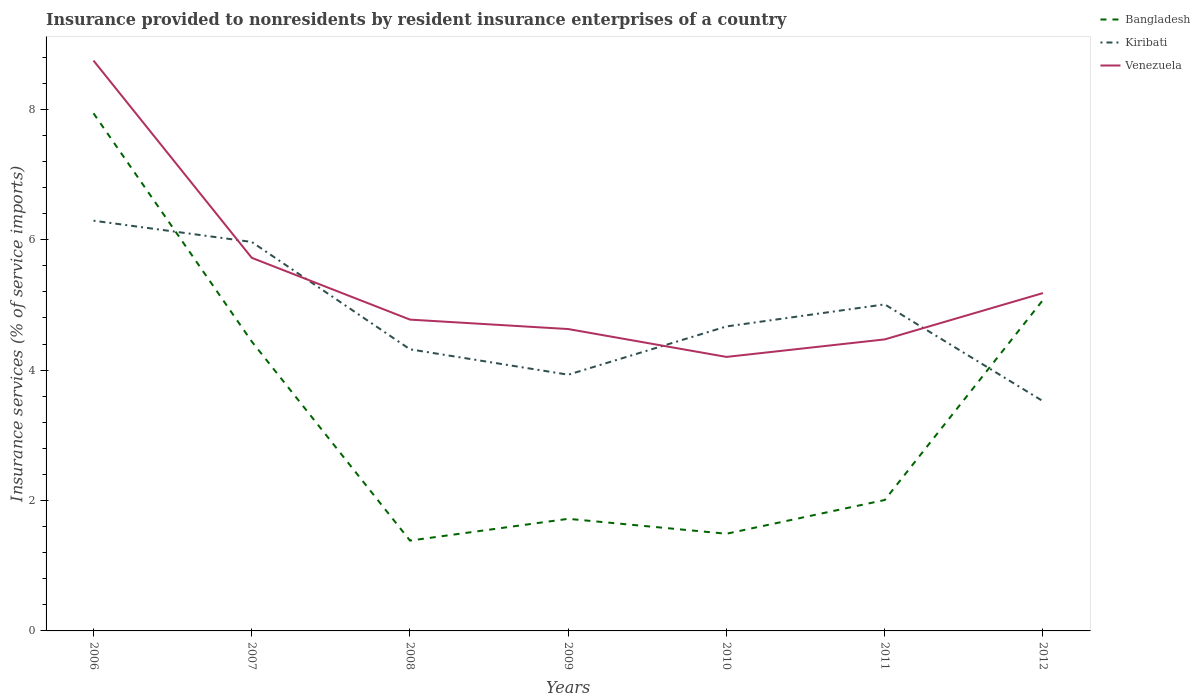Across all years, what is the maximum insurance provided to nonresidents in Bangladesh?
Ensure brevity in your answer.  1.39. What is the total insurance provided to nonresidents in Kiribati in the graph?
Provide a succinct answer. 1.48. What is the difference between the highest and the second highest insurance provided to nonresidents in Venezuela?
Your answer should be compact. 4.55. What is the difference between the highest and the lowest insurance provided to nonresidents in Kiribati?
Keep it short and to the point. 3. What is the difference between two consecutive major ticks on the Y-axis?
Give a very brief answer. 2. Where does the legend appear in the graph?
Give a very brief answer. Top right. How are the legend labels stacked?
Make the answer very short. Vertical. What is the title of the graph?
Offer a very short reply. Insurance provided to nonresidents by resident insurance enterprises of a country. Does "India" appear as one of the legend labels in the graph?
Ensure brevity in your answer.  No. What is the label or title of the X-axis?
Your response must be concise. Years. What is the label or title of the Y-axis?
Provide a succinct answer. Insurance services (% of service imports). What is the Insurance services (% of service imports) of Bangladesh in 2006?
Offer a terse response. 7.94. What is the Insurance services (% of service imports) in Kiribati in 2006?
Offer a very short reply. 6.29. What is the Insurance services (% of service imports) in Venezuela in 2006?
Make the answer very short. 8.75. What is the Insurance services (% of service imports) in Bangladesh in 2007?
Provide a succinct answer. 4.44. What is the Insurance services (% of service imports) in Kiribati in 2007?
Your answer should be compact. 5.97. What is the Insurance services (% of service imports) of Venezuela in 2007?
Provide a succinct answer. 5.72. What is the Insurance services (% of service imports) in Bangladesh in 2008?
Your answer should be very brief. 1.39. What is the Insurance services (% of service imports) of Kiribati in 2008?
Your answer should be compact. 4.32. What is the Insurance services (% of service imports) of Venezuela in 2008?
Offer a terse response. 4.77. What is the Insurance services (% of service imports) in Bangladesh in 2009?
Make the answer very short. 1.72. What is the Insurance services (% of service imports) in Kiribati in 2009?
Your response must be concise. 3.93. What is the Insurance services (% of service imports) in Venezuela in 2009?
Your answer should be compact. 4.63. What is the Insurance services (% of service imports) in Bangladesh in 2010?
Offer a very short reply. 1.49. What is the Insurance services (% of service imports) of Kiribati in 2010?
Make the answer very short. 4.67. What is the Insurance services (% of service imports) of Venezuela in 2010?
Offer a very short reply. 4.2. What is the Insurance services (% of service imports) in Bangladesh in 2011?
Your answer should be very brief. 2.01. What is the Insurance services (% of service imports) in Kiribati in 2011?
Offer a terse response. 5.01. What is the Insurance services (% of service imports) of Venezuela in 2011?
Keep it short and to the point. 4.47. What is the Insurance services (% of service imports) of Bangladesh in 2012?
Ensure brevity in your answer.  5.08. What is the Insurance services (% of service imports) in Kiribati in 2012?
Your response must be concise. 3.52. What is the Insurance services (% of service imports) of Venezuela in 2012?
Make the answer very short. 5.18. Across all years, what is the maximum Insurance services (% of service imports) of Bangladesh?
Your answer should be compact. 7.94. Across all years, what is the maximum Insurance services (% of service imports) of Kiribati?
Your answer should be very brief. 6.29. Across all years, what is the maximum Insurance services (% of service imports) of Venezuela?
Keep it short and to the point. 8.75. Across all years, what is the minimum Insurance services (% of service imports) in Bangladesh?
Give a very brief answer. 1.39. Across all years, what is the minimum Insurance services (% of service imports) of Kiribati?
Ensure brevity in your answer.  3.52. Across all years, what is the minimum Insurance services (% of service imports) of Venezuela?
Provide a short and direct response. 4.2. What is the total Insurance services (% of service imports) of Bangladesh in the graph?
Ensure brevity in your answer.  24.06. What is the total Insurance services (% of service imports) of Kiribati in the graph?
Your answer should be very brief. 33.71. What is the total Insurance services (% of service imports) of Venezuela in the graph?
Offer a terse response. 37.73. What is the difference between the Insurance services (% of service imports) in Bangladesh in 2006 and that in 2007?
Make the answer very short. 3.5. What is the difference between the Insurance services (% of service imports) of Kiribati in 2006 and that in 2007?
Make the answer very short. 0.33. What is the difference between the Insurance services (% of service imports) of Venezuela in 2006 and that in 2007?
Provide a succinct answer. 3.03. What is the difference between the Insurance services (% of service imports) of Bangladesh in 2006 and that in 2008?
Give a very brief answer. 6.55. What is the difference between the Insurance services (% of service imports) of Kiribati in 2006 and that in 2008?
Ensure brevity in your answer.  1.97. What is the difference between the Insurance services (% of service imports) of Venezuela in 2006 and that in 2008?
Provide a succinct answer. 3.97. What is the difference between the Insurance services (% of service imports) of Bangladesh in 2006 and that in 2009?
Ensure brevity in your answer.  6.22. What is the difference between the Insurance services (% of service imports) of Kiribati in 2006 and that in 2009?
Offer a terse response. 2.36. What is the difference between the Insurance services (% of service imports) of Venezuela in 2006 and that in 2009?
Provide a short and direct response. 4.12. What is the difference between the Insurance services (% of service imports) of Bangladesh in 2006 and that in 2010?
Your answer should be compact. 6.45. What is the difference between the Insurance services (% of service imports) of Kiribati in 2006 and that in 2010?
Make the answer very short. 1.62. What is the difference between the Insurance services (% of service imports) of Venezuela in 2006 and that in 2010?
Provide a short and direct response. 4.55. What is the difference between the Insurance services (% of service imports) in Bangladesh in 2006 and that in 2011?
Your response must be concise. 5.93. What is the difference between the Insurance services (% of service imports) in Kiribati in 2006 and that in 2011?
Offer a terse response. 1.28. What is the difference between the Insurance services (% of service imports) in Venezuela in 2006 and that in 2011?
Keep it short and to the point. 4.28. What is the difference between the Insurance services (% of service imports) of Bangladesh in 2006 and that in 2012?
Your answer should be compact. 2.86. What is the difference between the Insurance services (% of service imports) of Kiribati in 2006 and that in 2012?
Make the answer very short. 2.77. What is the difference between the Insurance services (% of service imports) of Venezuela in 2006 and that in 2012?
Make the answer very short. 3.57. What is the difference between the Insurance services (% of service imports) of Bangladesh in 2007 and that in 2008?
Offer a terse response. 3.05. What is the difference between the Insurance services (% of service imports) in Kiribati in 2007 and that in 2008?
Offer a terse response. 1.65. What is the difference between the Insurance services (% of service imports) in Venezuela in 2007 and that in 2008?
Provide a succinct answer. 0.95. What is the difference between the Insurance services (% of service imports) in Bangladesh in 2007 and that in 2009?
Keep it short and to the point. 2.72. What is the difference between the Insurance services (% of service imports) in Kiribati in 2007 and that in 2009?
Make the answer very short. 2.04. What is the difference between the Insurance services (% of service imports) of Venezuela in 2007 and that in 2009?
Ensure brevity in your answer.  1.09. What is the difference between the Insurance services (% of service imports) of Bangladesh in 2007 and that in 2010?
Make the answer very short. 2.95. What is the difference between the Insurance services (% of service imports) in Kiribati in 2007 and that in 2010?
Make the answer very short. 1.3. What is the difference between the Insurance services (% of service imports) in Venezuela in 2007 and that in 2010?
Ensure brevity in your answer.  1.52. What is the difference between the Insurance services (% of service imports) in Bangladesh in 2007 and that in 2011?
Make the answer very short. 2.43. What is the difference between the Insurance services (% of service imports) in Kiribati in 2007 and that in 2011?
Your answer should be compact. 0.96. What is the difference between the Insurance services (% of service imports) of Venezuela in 2007 and that in 2011?
Your answer should be very brief. 1.25. What is the difference between the Insurance services (% of service imports) of Bangladesh in 2007 and that in 2012?
Your answer should be compact. -0.64. What is the difference between the Insurance services (% of service imports) of Kiribati in 2007 and that in 2012?
Keep it short and to the point. 2.44. What is the difference between the Insurance services (% of service imports) of Venezuela in 2007 and that in 2012?
Provide a succinct answer. 0.54. What is the difference between the Insurance services (% of service imports) in Bangladesh in 2008 and that in 2009?
Make the answer very short. -0.33. What is the difference between the Insurance services (% of service imports) of Kiribati in 2008 and that in 2009?
Your answer should be compact. 0.39. What is the difference between the Insurance services (% of service imports) in Venezuela in 2008 and that in 2009?
Provide a succinct answer. 0.14. What is the difference between the Insurance services (% of service imports) of Bangladesh in 2008 and that in 2010?
Offer a very short reply. -0.1. What is the difference between the Insurance services (% of service imports) of Kiribati in 2008 and that in 2010?
Offer a very short reply. -0.35. What is the difference between the Insurance services (% of service imports) in Venezuela in 2008 and that in 2010?
Ensure brevity in your answer.  0.57. What is the difference between the Insurance services (% of service imports) in Bangladesh in 2008 and that in 2011?
Your response must be concise. -0.62. What is the difference between the Insurance services (% of service imports) in Kiribati in 2008 and that in 2011?
Ensure brevity in your answer.  -0.69. What is the difference between the Insurance services (% of service imports) of Venezuela in 2008 and that in 2011?
Keep it short and to the point. 0.3. What is the difference between the Insurance services (% of service imports) of Bangladesh in 2008 and that in 2012?
Give a very brief answer. -3.69. What is the difference between the Insurance services (% of service imports) in Kiribati in 2008 and that in 2012?
Make the answer very short. 0.8. What is the difference between the Insurance services (% of service imports) in Venezuela in 2008 and that in 2012?
Provide a short and direct response. -0.41. What is the difference between the Insurance services (% of service imports) in Bangladesh in 2009 and that in 2010?
Ensure brevity in your answer.  0.23. What is the difference between the Insurance services (% of service imports) of Kiribati in 2009 and that in 2010?
Provide a succinct answer. -0.74. What is the difference between the Insurance services (% of service imports) in Venezuela in 2009 and that in 2010?
Your answer should be compact. 0.43. What is the difference between the Insurance services (% of service imports) in Bangladesh in 2009 and that in 2011?
Your response must be concise. -0.29. What is the difference between the Insurance services (% of service imports) in Kiribati in 2009 and that in 2011?
Make the answer very short. -1.08. What is the difference between the Insurance services (% of service imports) in Venezuela in 2009 and that in 2011?
Provide a succinct answer. 0.16. What is the difference between the Insurance services (% of service imports) of Bangladesh in 2009 and that in 2012?
Provide a succinct answer. -3.36. What is the difference between the Insurance services (% of service imports) in Kiribati in 2009 and that in 2012?
Your response must be concise. 0.41. What is the difference between the Insurance services (% of service imports) of Venezuela in 2009 and that in 2012?
Offer a very short reply. -0.55. What is the difference between the Insurance services (% of service imports) in Bangladesh in 2010 and that in 2011?
Provide a succinct answer. -0.52. What is the difference between the Insurance services (% of service imports) in Kiribati in 2010 and that in 2011?
Your answer should be very brief. -0.34. What is the difference between the Insurance services (% of service imports) of Venezuela in 2010 and that in 2011?
Your answer should be very brief. -0.27. What is the difference between the Insurance services (% of service imports) in Bangladesh in 2010 and that in 2012?
Your answer should be very brief. -3.59. What is the difference between the Insurance services (% of service imports) in Kiribati in 2010 and that in 2012?
Your response must be concise. 1.15. What is the difference between the Insurance services (% of service imports) in Venezuela in 2010 and that in 2012?
Offer a terse response. -0.98. What is the difference between the Insurance services (% of service imports) in Bangladesh in 2011 and that in 2012?
Give a very brief answer. -3.07. What is the difference between the Insurance services (% of service imports) in Kiribati in 2011 and that in 2012?
Your answer should be compact. 1.48. What is the difference between the Insurance services (% of service imports) of Venezuela in 2011 and that in 2012?
Offer a very short reply. -0.71. What is the difference between the Insurance services (% of service imports) of Bangladesh in 2006 and the Insurance services (% of service imports) of Kiribati in 2007?
Provide a succinct answer. 1.97. What is the difference between the Insurance services (% of service imports) in Bangladesh in 2006 and the Insurance services (% of service imports) in Venezuela in 2007?
Keep it short and to the point. 2.22. What is the difference between the Insurance services (% of service imports) of Kiribati in 2006 and the Insurance services (% of service imports) of Venezuela in 2007?
Offer a very short reply. 0.57. What is the difference between the Insurance services (% of service imports) in Bangladesh in 2006 and the Insurance services (% of service imports) in Kiribati in 2008?
Offer a terse response. 3.62. What is the difference between the Insurance services (% of service imports) in Bangladesh in 2006 and the Insurance services (% of service imports) in Venezuela in 2008?
Provide a short and direct response. 3.16. What is the difference between the Insurance services (% of service imports) in Kiribati in 2006 and the Insurance services (% of service imports) in Venezuela in 2008?
Make the answer very short. 1.52. What is the difference between the Insurance services (% of service imports) in Bangladesh in 2006 and the Insurance services (% of service imports) in Kiribati in 2009?
Provide a short and direct response. 4.01. What is the difference between the Insurance services (% of service imports) in Bangladesh in 2006 and the Insurance services (% of service imports) in Venezuela in 2009?
Keep it short and to the point. 3.31. What is the difference between the Insurance services (% of service imports) in Kiribati in 2006 and the Insurance services (% of service imports) in Venezuela in 2009?
Provide a short and direct response. 1.66. What is the difference between the Insurance services (% of service imports) in Bangladesh in 2006 and the Insurance services (% of service imports) in Kiribati in 2010?
Provide a succinct answer. 3.27. What is the difference between the Insurance services (% of service imports) in Bangladesh in 2006 and the Insurance services (% of service imports) in Venezuela in 2010?
Provide a succinct answer. 3.74. What is the difference between the Insurance services (% of service imports) of Kiribati in 2006 and the Insurance services (% of service imports) of Venezuela in 2010?
Ensure brevity in your answer.  2.09. What is the difference between the Insurance services (% of service imports) of Bangladesh in 2006 and the Insurance services (% of service imports) of Kiribati in 2011?
Your answer should be compact. 2.93. What is the difference between the Insurance services (% of service imports) of Bangladesh in 2006 and the Insurance services (% of service imports) of Venezuela in 2011?
Ensure brevity in your answer.  3.47. What is the difference between the Insurance services (% of service imports) of Kiribati in 2006 and the Insurance services (% of service imports) of Venezuela in 2011?
Your answer should be very brief. 1.82. What is the difference between the Insurance services (% of service imports) in Bangladesh in 2006 and the Insurance services (% of service imports) in Kiribati in 2012?
Provide a short and direct response. 4.42. What is the difference between the Insurance services (% of service imports) of Bangladesh in 2006 and the Insurance services (% of service imports) of Venezuela in 2012?
Provide a short and direct response. 2.76. What is the difference between the Insurance services (% of service imports) of Kiribati in 2006 and the Insurance services (% of service imports) of Venezuela in 2012?
Offer a terse response. 1.11. What is the difference between the Insurance services (% of service imports) in Bangladesh in 2007 and the Insurance services (% of service imports) in Kiribati in 2008?
Keep it short and to the point. 0.12. What is the difference between the Insurance services (% of service imports) in Bangladesh in 2007 and the Insurance services (% of service imports) in Venezuela in 2008?
Your answer should be very brief. -0.34. What is the difference between the Insurance services (% of service imports) of Kiribati in 2007 and the Insurance services (% of service imports) of Venezuela in 2008?
Your response must be concise. 1.19. What is the difference between the Insurance services (% of service imports) in Bangladesh in 2007 and the Insurance services (% of service imports) in Kiribati in 2009?
Your answer should be very brief. 0.51. What is the difference between the Insurance services (% of service imports) of Bangladesh in 2007 and the Insurance services (% of service imports) of Venezuela in 2009?
Offer a very short reply. -0.19. What is the difference between the Insurance services (% of service imports) in Kiribati in 2007 and the Insurance services (% of service imports) in Venezuela in 2009?
Offer a terse response. 1.34. What is the difference between the Insurance services (% of service imports) in Bangladesh in 2007 and the Insurance services (% of service imports) in Kiribati in 2010?
Offer a very short reply. -0.23. What is the difference between the Insurance services (% of service imports) of Bangladesh in 2007 and the Insurance services (% of service imports) of Venezuela in 2010?
Ensure brevity in your answer.  0.24. What is the difference between the Insurance services (% of service imports) of Kiribati in 2007 and the Insurance services (% of service imports) of Venezuela in 2010?
Keep it short and to the point. 1.76. What is the difference between the Insurance services (% of service imports) of Bangladesh in 2007 and the Insurance services (% of service imports) of Kiribati in 2011?
Your answer should be very brief. -0.57. What is the difference between the Insurance services (% of service imports) of Bangladesh in 2007 and the Insurance services (% of service imports) of Venezuela in 2011?
Your answer should be compact. -0.03. What is the difference between the Insurance services (% of service imports) of Kiribati in 2007 and the Insurance services (% of service imports) of Venezuela in 2011?
Provide a succinct answer. 1.49. What is the difference between the Insurance services (% of service imports) in Bangladesh in 2007 and the Insurance services (% of service imports) in Kiribati in 2012?
Your response must be concise. 0.92. What is the difference between the Insurance services (% of service imports) of Bangladesh in 2007 and the Insurance services (% of service imports) of Venezuela in 2012?
Provide a short and direct response. -0.74. What is the difference between the Insurance services (% of service imports) in Kiribati in 2007 and the Insurance services (% of service imports) in Venezuela in 2012?
Give a very brief answer. 0.78. What is the difference between the Insurance services (% of service imports) in Bangladesh in 2008 and the Insurance services (% of service imports) in Kiribati in 2009?
Provide a short and direct response. -2.54. What is the difference between the Insurance services (% of service imports) of Bangladesh in 2008 and the Insurance services (% of service imports) of Venezuela in 2009?
Make the answer very short. -3.24. What is the difference between the Insurance services (% of service imports) of Kiribati in 2008 and the Insurance services (% of service imports) of Venezuela in 2009?
Give a very brief answer. -0.31. What is the difference between the Insurance services (% of service imports) of Bangladesh in 2008 and the Insurance services (% of service imports) of Kiribati in 2010?
Give a very brief answer. -3.28. What is the difference between the Insurance services (% of service imports) of Bangladesh in 2008 and the Insurance services (% of service imports) of Venezuela in 2010?
Provide a succinct answer. -2.82. What is the difference between the Insurance services (% of service imports) of Kiribati in 2008 and the Insurance services (% of service imports) of Venezuela in 2010?
Offer a very short reply. 0.12. What is the difference between the Insurance services (% of service imports) in Bangladesh in 2008 and the Insurance services (% of service imports) in Kiribati in 2011?
Your answer should be very brief. -3.62. What is the difference between the Insurance services (% of service imports) of Bangladesh in 2008 and the Insurance services (% of service imports) of Venezuela in 2011?
Make the answer very short. -3.09. What is the difference between the Insurance services (% of service imports) in Kiribati in 2008 and the Insurance services (% of service imports) in Venezuela in 2011?
Keep it short and to the point. -0.15. What is the difference between the Insurance services (% of service imports) of Bangladesh in 2008 and the Insurance services (% of service imports) of Kiribati in 2012?
Provide a succinct answer. -2.14. What is the difference between the Insurance services (% of service imports) in Bangladesh in 2008 and the Insurance services (% of service imports) in Venezuela in 2012?
Your answer should be compact. -3.8. What is the difference between the Insurance services (% of service imports) of Kiribati in 2008 and the Insurance services (% of service imports) of Venezuela in 2012?
Ensure brevity in your answer.  -0.86. What is the difference between the Insurance services (% of service imports) in Bangladesh in 2009 and the Insurance services (% of service imports) in Kiribati in 2010?
Your answer should be very brief. -2.95. What is the difference between the Insurance services (% of service imports) in Bangladesh in 2009 and the Insurance services (% of service imports) in Venezuela in 2010?
Your answer should be very brief. -2.48. What is the difference between the Insurance services (% of service imports) in Kiribati in 2009 and the Insurance services (% of service imports) in Venezuela in 2010?
Offer a terse response. -0.27. What is the difference between the Insurance services (% of service imports) in Bangladesh in 2009 and the Insurance services (% of service imports) in Kiribati in 2011?
Offer a very short reply. -3.29. What is the difference between the Insurance services (% of service imports) of Bangladesh in 2009 and the Insurance services (% of service imports) of Venezuela in 2011?
Ensure brevity in your answer.  -2.75. What is the difference between the Insurance services (% of service imports) of Kiribati in 2009 and the Insurance services (% of service imports) of Venezuela in 2011?
Your response must be concise. -0.54. What is the difference between the Insurance services (% of service imports) of Bangladesh in 2009 and the Insurance services (% of service imports) of Kiribati in 2012?
Your response must be concise. -1.8. What is the difference between the Insurance services (% of service imports) of Bangladesh in 2009 and the Insurance services (% of service imports) of Venezuela in 2012?
Make the answer very short. -3.46. What is the difference between the Insurance services (% of service imports) of Kiribati in 2009 and the Insurance services (% of service imports) of Venezuela in 2012?
Your response must be concise. -1.25. What is the difference between the Insurance services (% of service imports) in Bangladesh in 2010 and the Insurance services (% of service imports) in Kiribati in 2011?
Your response must be concise. -3.52. What is the difference between the Insurance services (% of service imports) in Bangladesh in 2010 and the Insurance services (% of service imports) in Venezuela in 2011?
Offer a terse response. -2.98. What is the difference between the Insurance services (% of service imports) in Kiribati in 2010 and the Insurance services (% of service imports) in Venezuela in 2011?
Offer a terse response. 0.2. What is the difference between the Insurance services (% of service imports) in Bangladesh in 2010 and the Insurance services (% of service imports) in Kiribati in 2012?
Ensure brevity in your answer.  -2.03. What is the difference between the Insurance services (% of service imports) in Bangladesh in 2010 and the Insurance services (% of service imports) in Venezuela in 2012?
Offer a terse response. -3.69. What is the difference between the Insurance services (% of service imports) of Kiribati in 2010 and the Insurance services (% of service imports) of Venezuela in 2012?
Your response must be concise. -0.51. What is the difference between the Insurance services (% of service imports) in Bangladesh in 2011 and the Insurance services (% of service imports) in Kiribati in 2012?
Your response must be concise. -1.52. What is the difference between the Insurance services (% of service imports) in Bangladesh in 2011 and the Insurance services (% of service imports) in Venezuela in 2012?
Provide a succinct answer. -3.17. What is the difference between the Insurance services (% of service imports) in Kiribati in 2011 and the Insurance services (% of service imports) in Venezuela in 2012?
Offer a terse response. -0.17. What is the average Insurance services (% of service imports) in Bangladesh per year?
Ensure brevity in your answer.  3.44. What is the average Insurance services (% of service imports) in Kiribati per year?
Your answer should be very brief. 4.82. What is the average Insurance services (% of service imports) in Venezuela per year?
Your answer should be very brief. 5.39. In the year 2006, what is the difference between the Insurance services (% of service imports) of Bangladesh and Insurance services (% of service imports) of Kiribati?
Provide a succinct answer. 1.65. In the year 2006, what is the difference between the Insurance services (% of service imports) of Bangladesh and Insurance services (% of service imports) of Venezuela?
Offer a very short reply. -0.81. In the year 2006, what is the difference between the Insurance services (% of service imports) in Kiribati and Insurance services (% of service imports) in Venezuela?
Keep it short and to the point. -2.46. In the year 2007, what is the difference between the Insurance services (% of service imports) of Bangladesh and Insurance services (% of service imports) of Kiribati?
Your response must be concise. -1.53. In the year 2007, what is the difference between the Insurance services (% of service imports) of Bangladesh and Insurance services (% of service imports) of Venezuela?
Your answer should be compact. -1.28. In the year 2007, what is the difference between the Insurance services (% of service imports) of Kiribati and Insurance services (% of service imports) of Venezuela?
Offer a terse response. 0.24. In the year 2008, what is the difference between the Insurance services (% of service imports) of Bangladesh and Insurance services (% of service imports) of Kiribati?
Your answer should be very brief. -2.93. In the year 2008, what is the difference between the Insurance services (% of service imports) of Bangladesh and Insurance services (% of service imports) of Venezuela?
Ensure brevity in your answer.  -3.39. In the year 2008, what is the difference between the Insurance services (% of service imports) in Kiribati and Insurance services (% of service imports) in Venezuela?
Your answer should be compact. -0.46. In the year 2009, what is the difference between the Insurance services (% of service imports) in Bangladesh and Insurance services (% of service imports) in Kiribati?
Your answer should be very brief. -2.21. In the year 2009, what is the difference between the Insurance services (% of service imports) in Bangladesh and Insurance services (% of service imports) in Venezuela?
Your answer should be compact. -2.91. In the year 2010, what is the difference between the Insurance services (% of service imports) in Bangladesh and Insurance services (% of service imports) in Kiribati?
Provide a succinct answer. -3.18. In the year 2010, what is the difference between the Insurance services (% of service imports) of Bangladesh and Insurance services (% of service imports) of Venezuela?
Your answer should be very brief. -2.71. In the year 2010, what is the difference between the Insurance services (% of service imports) of Kiribati and Insurance services (% of service imports) of Venezuela?
Provide a succinct answer. 0.47. In the year 2011, what is the difference between the Insurance services (% of service imports) in Bangladesh and Insurance services (% of service imports) in Kiribati?
Your answer should be very brief. -3. In the year 2011, what is the difference between the Insurance services (% of service imports) in Bangladesh and Insurance services (% of service imports) in Venezuela?
Keep it short and to the point. -2.46. In the year 2011, what is the difference between the Insurance services (% of service imports) in Kiribati and Insurance services (% of service imports) in Venezuela?
Make the answer very short. 0.54. In the year 2012, what is the difference between the Insurance services (% of service imports) in Bangladesh and Insurance services (% of service imports) in Kiribati?
Your answer should be compact. 1.55. In the year 2012, what is the difference between the Insurance services (% of service imports) of Bangladesh and Insurance services (% of service imports) of Venezuela?
Keep it short and to the point. -0.11. In the year 2012, what is the difference between the Insurance services (% of service imports) in Kiribati and Insurance services (% of service imports) in Venezuela?
Keep it short and to the point. -1.66. What is the ratio of the Insurance services (% of service imports) in Bangladesh in 2006 to that in 2007?
Your response must be concise. 1.79. What is the ratio of the Insurance services (% of service imports) in Kiribati in 2006 to that in 2007?
Provide a succinct answer. 1.05. What is the ratio of the Insurance services (% of service imports) in Venezuela in 2006 to that in 2007?
Your answer should be very brief. 1.53. What is the ratio of the Insurance services (% of service imports) of Bangladesh in 2006 to that in 2008?
Your answer should be very brief. 5.73. What is the ratio of the Insurance services (% of service imports) of Kiribati in 2006 to that in 2008?
Keep it short and to the point. 1.46. What is the ratio of the Insurance services (% of service imports) of Venezuela in 2006 to that in 2008?
Your answer should be compact. 1.83. What is the ratio of the Insurance services (% of service imports) of Bangladesh in 2006 to that in 2009?
Your response must be concise. 4.62. What is the ratio of the Insurance services (% of service imports) in Kiribati in 2006 to that in 2009?
Your answer should be very brief. 1.6. What is the ratio of the Insurance services (% of service imports) in Venezuela in 2006 to that in 2009?
Your answer should be compact. 1.89. What is the ratio of the Insurance services (% of service imports) of Bangladesh in 2006 to that in 2010?
Offer a very short reply. 5.33. What is the ratio of the Insurance services (% of service imports) of Kiribati in 2006 to that in 2010?
Your answer should be compact. 1.35. What is the ratio of the Insurance services (% of service imports) in Venezuela in 2006 to that in 2010?
Keep it short and to the point. 2.08. What is the ratio of the Insurance services (% of service imports) in Bangladesh in 2006 to that in 2011?
Ensure brevity in your answer.  3.95. What is the ratio of the Insurance services (% of service imports) of Kiribati in 2006 to that in 2011?
Keep it short and to the point. 1.26. What is the ratio of the Insurance services (% of service imports) of Venezuela in 2006 to that in 2011?
Your response must be concise. 1.96. What is the ratio of the Insurance services (% of service imports) in Bangladesh in 2006 to that in 2012?
Provide a succinct answer. 1.56. What is the ratio of the Insurance services (% of service imports) in Kiribati in 2006 to that in 2012?
Your answer should be compact. 1.79. What is the ratio of the Insurance services (% of service imports) of Venezuela in 2006 to that in 2012?
Offer a very short reply. 1.69. What is the ratio of the Insurance services (% of service imports) of Bangladesh in 2007 to that in 2008?
Provide a succinct answer. 3.2. What is the ratio of the Insurance services (% of service imports) in Kiribati in 2007 to that in 2008?
Provide a short and direct response. 1.38. What is the ratio of the Insurance services (% of service imports) in Venezuela in 2007 to that in 2008?
Provide a short and direct response. 1.2. What is the ratio of the Insurance services (% of service imports) of Bangladesh in 2007 to that in 2009?
Make the answer very short. 2.58. What is the ratio of the Insurance services (% of service imports) of Kiribati in 2007 to that in 2009?
Your answer should be compact. 1.52. What is the ratio of the Insurance services (% of service imports) in Venezuela in 2007 to that in 2009?
Keep it short and to the point. 1.24. What is the ratio of the Insurance services (% of service imports) in Bangladesh in 2007 to that in 2010?
Your response must be concise. 2.98. What is the ratio of the Insurance services (% of service imports) of Kiribati in 2007 to that in 2010?
Give a very brief answer. 1.28. What is the ratio of the Insurance services (% of service imports) of Venezuela in 2007 to that in 2010?
Offer a very short reply. 1.36. What is the ratio of the Insurance services (% of service imports) of Bangladesh in 2007 to that in 2011?
Keep it short and to the point. 2.21. What is the ratio of the Insurance services (% of service imports) of Kiribati in 2007 to that in 2011?
Your answer should be very brief. 1.19. What is the ratio of the Insurance services (% of service imports) of Venezuela in 2007 to that in 2011?
Your answer should be very brief. 1.28. What is the ratio of the Insurance services (% of service imports) in Bangladesh in 2007 to that in 2012?
Make the answer very short. 0.87. What is the ratio of the Insurance services (% of service imports) of Kiribati in 2007 to that in 2012?
Ensure brevity in your answer.  1.69. What is the ratio of the Insurance services (% of service imports) of Venezuela in 2007 to that in 2012?
Keep it short and to the point. 1.1. What is the ratio of the Insurance services (% of service imports) of Bangladesh in 2008 to that in 2009?
Your answer should be compact. 0.81. What is the ratio of the Insurance services (% of service imports) in Kiribati in 2008 to that in 2009?
Offer a terse response. 1.1. What is the ratio of the Insurance services (% of service imports) of Venezuela in 2008 to that in 2009?
Provide a short and direct response. 1.03. What is the ratio of the Insurance services (% of service imports) of Bangladesh in 2008 to that in 2010?
Offer a very short reply. 0.93. What is the ratio of the Insurance services (% of service imports) of Kiribati in 2008 to that in 2010?
Keep it short and to the point. 0.92. What is the ratio of the Insurance services (% of service imports) of Venezuela in 2008 to that in 2010?
Provide a succinct answer. 1.14. What is the ratio of the Insurance services (% of service imports) in Bangladesh in 2008 to that in 2011?
Your answer should be very brief. 0.69. What is the ratio of the Insurance services (% of service imports) in Kiribati in 2008 to that in 2011?
Make the answer very short. 0.86. What is the ratio of the Insurance services (% of service imports) of Venezuela in 2008 to that in 2011?
Keep it short and to the point. 1.07. What is the ratio of the Insurance services (% of service imports) of Bangladesh in 2008 to that in 2012?
Your answer should be compact. 0.27. What is the ratio of the Insurance services (% of service imports) of Kiribati in 2008 to that in 2012?
Offer a very short reply. 1.23. What is the ratio of the Insurance services (% of service imports) in Venezuela in 2008 to that in 2012?
Provide a short and direct response. 0.92. What is the ratio of the Insurance services (% of service imports) of Bangladesh in 2009 to that in 2010?
Provide a short and direct response. 1.15. What is the ratio of the Insurance services (% of service imports) in Kiribati in 2009 to that in 2010?
Your answer should be very brief. 0.84. What is the ratio of the Insurance services (% of service imports) in Venezuela in 2009 to that in 2010?
Your response must be concise. 1.1. What is the ratio of the Insurance services (% of service imports) in Bangladesh in 2009 to that in 2011?
Offer a very short reply. 0.86. What is the ratio of the Insurance services (% of service imports) in Kiribati in 2009 to that in 2011?
Keep it short and to the point. 0.78. What is the ratio of the Insurance services (% of service imports) of Venezuela in 2009 to that in 2011?
Your answer should be very brief. 1.04. What is the ratio of the Insurance services (% of service imports) in Bangladesh in 2009 to that in 2012?
Your response must be concise. 0.34. What is the ratio of the Insurance services (% of service imports) of Kiribati in 2009 to that in 2012?
Give a very brief answer. 1.12. What is the ratio of the Insurance services (% of service imports) of Venezuela in 2009 to that in 2012?
Make the answer very short. 0.89. What is the ratio of the Insurance services (% of service imports) of Bangladesh in 2010 to that in 2011?
Your answer should be very brief. 0.74. What is the ratio of the Insurance services (% of service imports) of Kiribati in 2010 to that in 2011?
Provide a succinct answer. 0.93. What is the ratio of the Insurance services (% of service imports) in Venezuela in 2010 to that in 2011?
Offer a terse response. 0.94. What is the ratio of the Insurance services (% of service imports) of Bangladesh in 2010 to that in 2012?
Provide a short and direct response. 0.29. What is the ratio of the Insurance services (% of service imports) in Kiribati in 2010 to that in 2012?
Provide a short and direct response. 1.33. What is the ratio of the Insurance services (% of service imports) in Venezuela in 2010 to that in 2012?
Your answer should be very brief. 0.81. What is the ratio of the Insurance services (% of service imports) in Bangladesh in 2011 to that in 2012?
Offer a terse response. 0.4. What is the ratio of the Insurance services (% of service imports) in Kiribati in 2011 to that in 2012?
Provide a succinct answer. 1.42. What is the ratio of the Insurance services (% of service imports) in Venezuela in 2011 to that in 2012?
Provide a succinct answer. 0.86. What is the difference between the highest and the second highest Insurance services (% of service imports) of Bangladesh?
Make the answer very short. 2.86. What is the difference between the highest and the second highest Insurance services (% of service imports) of Kiribati?
Offer a very short reply. 0.33. What is the difference between the highest and the second highest Insurance services (% of service imports) in Venezuela?
Your answer should be compact. 3.03. What is the difference between the highest and the lowest Insurance services (% of service imports) in Bangladesh?
Make the answer very short. 6.55. What is the difference between the highest and the lowest Insurance services (% of service imports) of Kiribati?
Your response must be concise. 2.77. What is the difference between the highest and the lowest Insurance services (% of service imports) in Venezuela?
Provide a short and direct response. 4.55. 